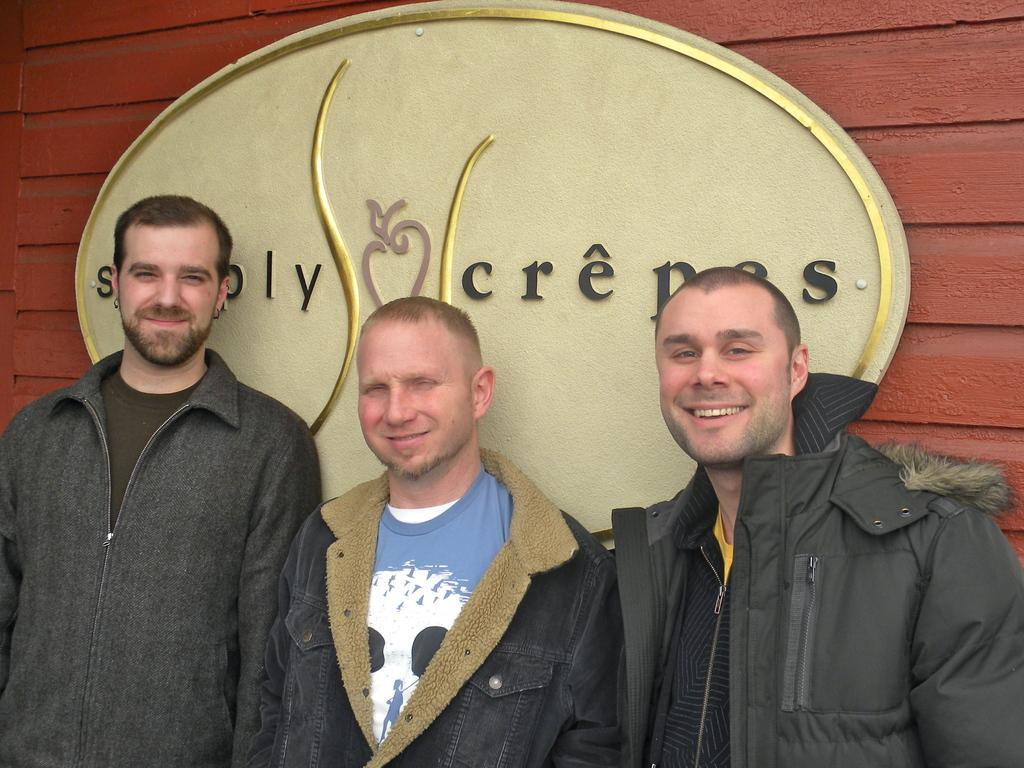How many people are in the image? There are three people in the image. Where are the people located in relation to the wall? The people are standing near a wall. What is the facial expression of the people in the image? The people are smiling. What are the people doing in the image? The people are watching something. Can you describe any additional objects or features in the image? There is a name board in the image. What type of butter is being used to style the hair of the people in the image? There is no butter or hair styling present in the image; the people are simply standing near a wall and watching something. 